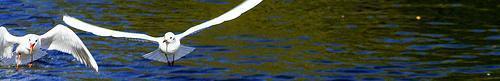How many birds are pictured?
Give a very brief answer. 2. How many legs does each bird have?
Give a very brief answer. 2. 